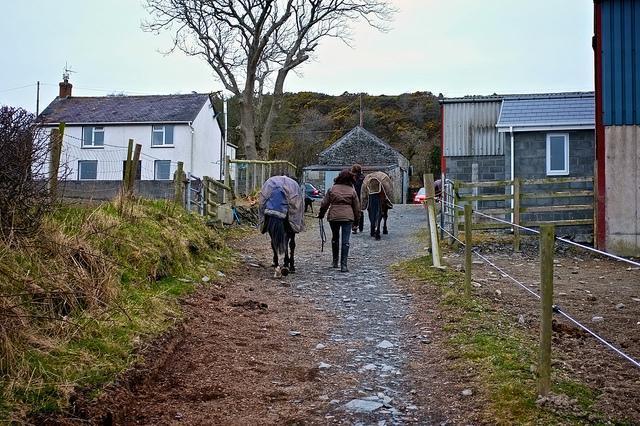How many buildings are visible?
Give a very brief answer. 5. How many people are visible?
Give a very brief answer. 1. 